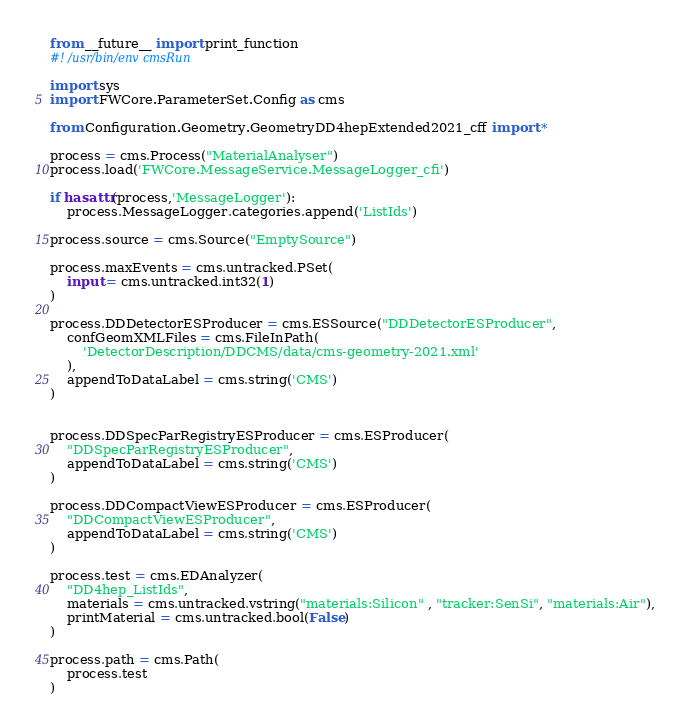<code> <loc_0><loc_0><loc_500><loc_500><_Python_>from __future__ import print_function
#! /usr/bin/env cmsRun

import sys
import FWCore.ParameterSet.Config as cms

from Configuration.Geometry.GeometryDD4hepExtended2021_cff import *

process = cms.Process("MaterialAnalyser")
process.load('FWCore.MessageService.MessageLogger_cfi')

if hasattr(process,'MessageLogger'):
    process.MessageLogger.categories.append('ListIds')

process.source = cms.Source("EmptySource")

process.maxEvents = cms.untracked.PSet(
    input = cms.untracked.int32(1)
)

process.DDDetectorESProducer = cms.ESSource("DDDetectorESProducer",
    confGeomXMLFiles = cms.FileInPath(
        'DetectorDescription/DDCMS/data/cms-geometry-2021.xml'
    ),
    appendToDataLabel = cms.string('CMS')
)


process.DDSpecParRegistryESProducer = cms.ESProducer(
    "DDSpecParRegistryESProducer",
    appendToDataLabel = cms.string('CMS')
)

process.DDCompactViewESProducer = cms.ESProducer(
    "DDCompactViewESProducer",
    appendToDataLabel = cms.string('CMS')
)

process.test = cms.EDAnalyzer(
    "DD4hep_ListIds",
    materials = cms.untracked.vstring("materials:Silicon" , "tracker:SenSi", "materials:Air"),
    printMaterial = cms.untracked.bool(False)
)

process.path = cms.Path(
    process.test
)
</code> 